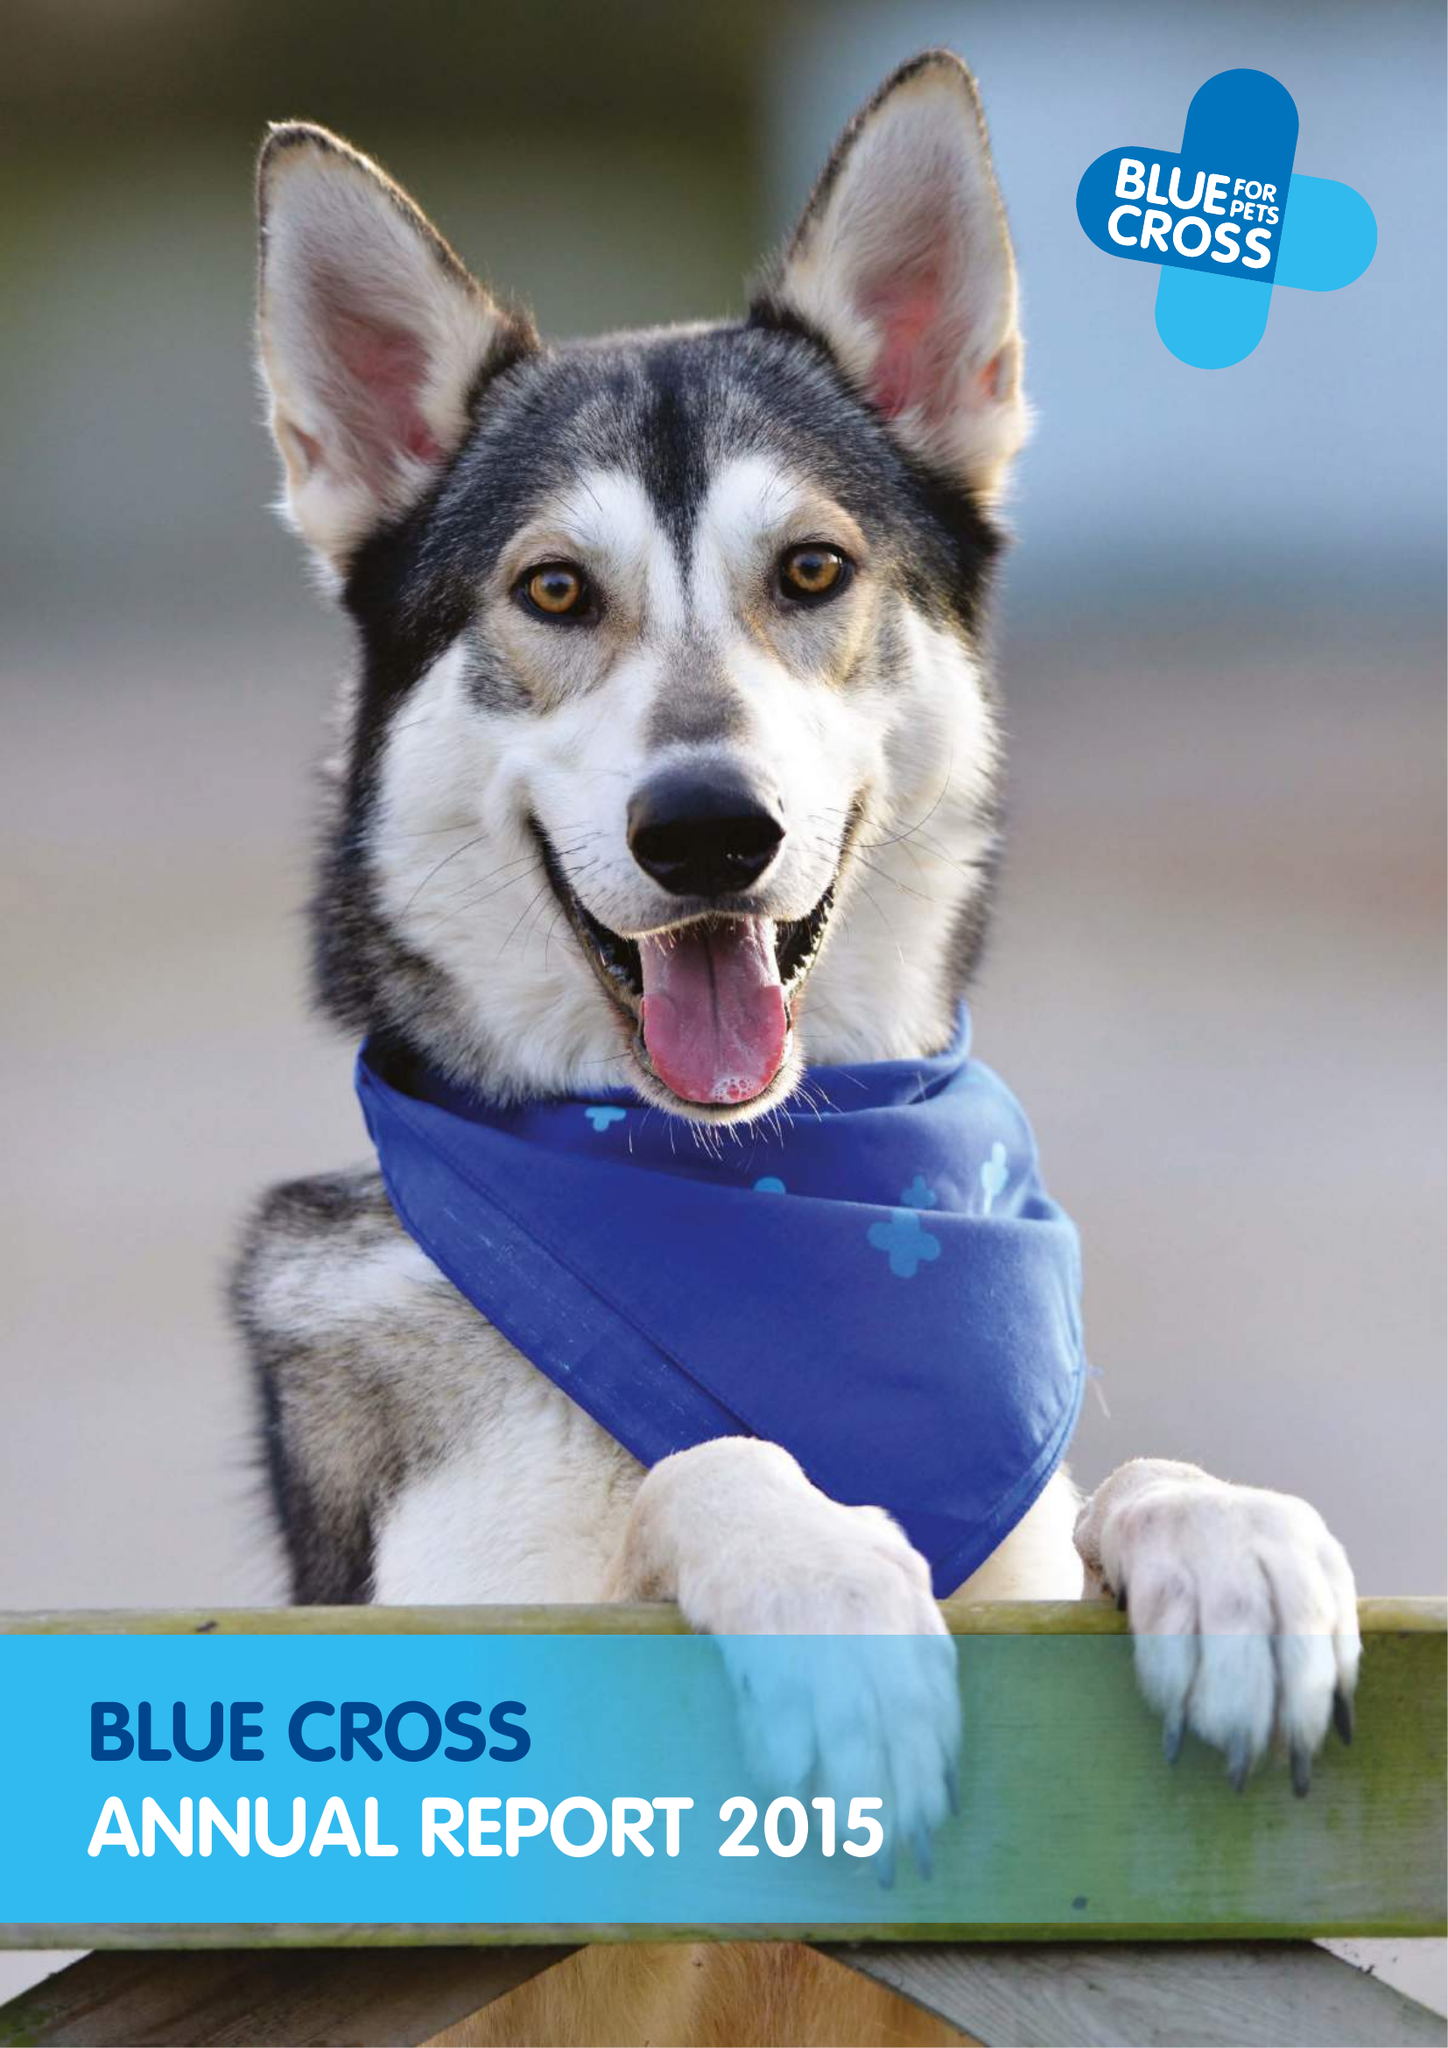What is the value for the spending_annually_in_british_pounds?
Answer the question using a single word or phrase. 39617000.00 